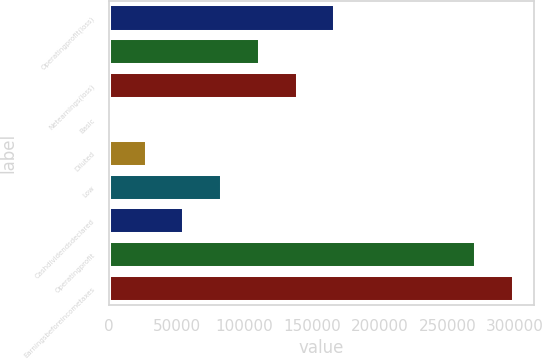Convert chart. <chart><loc_0><loc_0><loc_500><loc_500><bar_chart><fcel>Operatingprofit(loss)<fcel>Unnamed: 1<fcel>Netearnings(loss)<fcel>Basic<fcel>Diluted<fcel>Low<fcel>Cashdividendsdeclared<fcel>Operatingprofit<fcel>Earningsbeforeincometaxes<nl><fcel>167152<fcel>111434<fcel>139293<fcel>0.07<fcel>27858.7<fcel>83575.8<fcel>55717.2<fcel>271088<fcel>298947<nl></chart> 